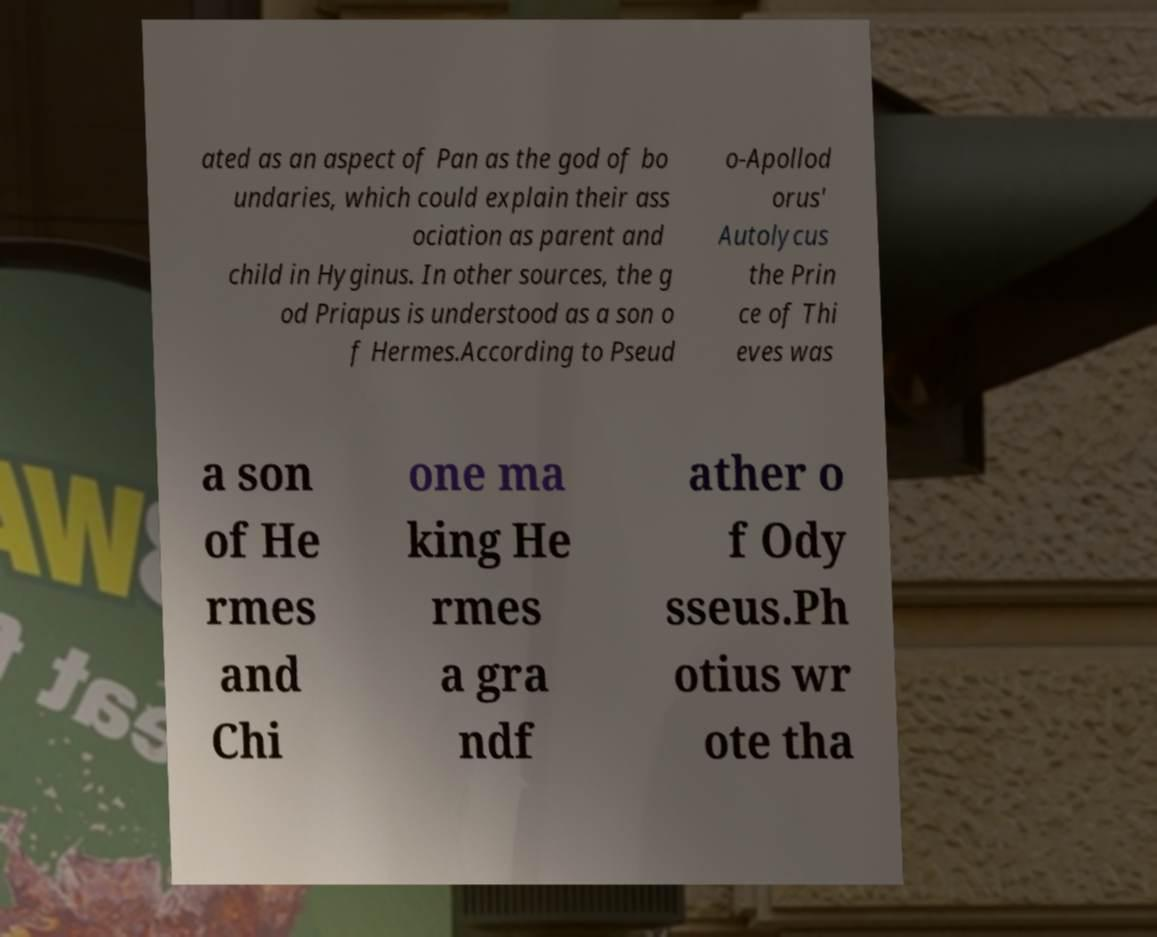What messages or text are displayed in this image? I need them in a readable, typed format. ated as an aspect of Pan as the god of bo undaries, which could explain their ass ociation as parent and child in Hyginus. In other sources, the g od Priapus is understood as a son o f Hermes.According to Pseud o-Apollod orus' Autolycus the Prin ce of Thi eves was a son of He rmes and Chi one ma king He rmes a gra ndf ather o f Ody sseus.Ph otius wr ote tha 